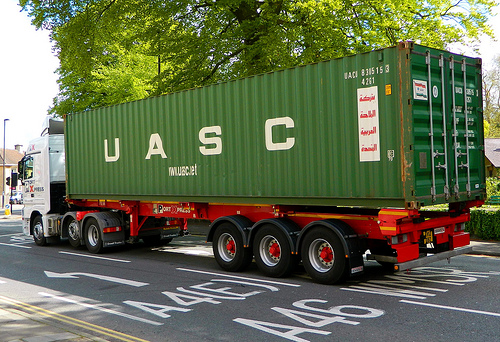Do you see any houses to the right of the green truck? Yes, there are houses located to the right of the green truck. 